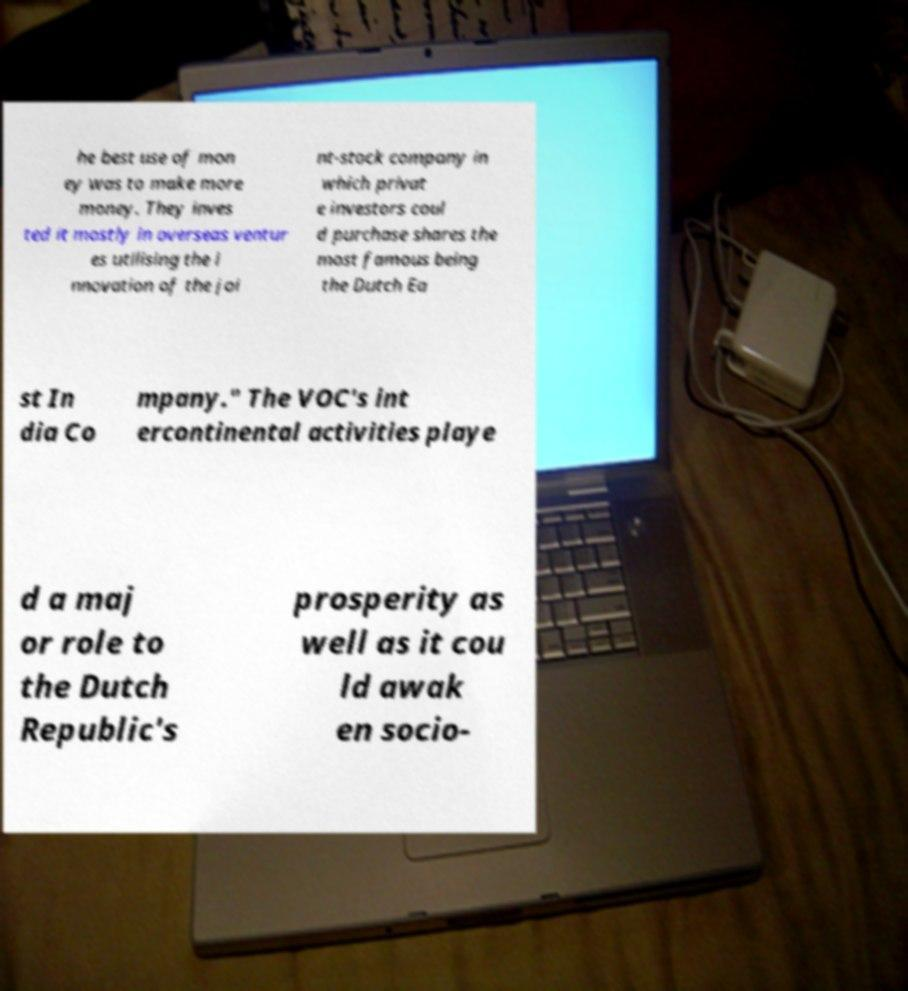What messages or text are displayed in this image? I need them in a readable, typed format. he best use of mon ey was to make more money. They inves ted it mostly in overseas ventur es utilising the i nnovation of the joi nt-stock company in which privat e investors coul d purchase shares the most famous being the Dutch Ea st In dia Co mpany." The VOC's int ercontinental activities playe d a maj or role to the Dutch Republic's prosperity as well as it cou ld awak en socio- 